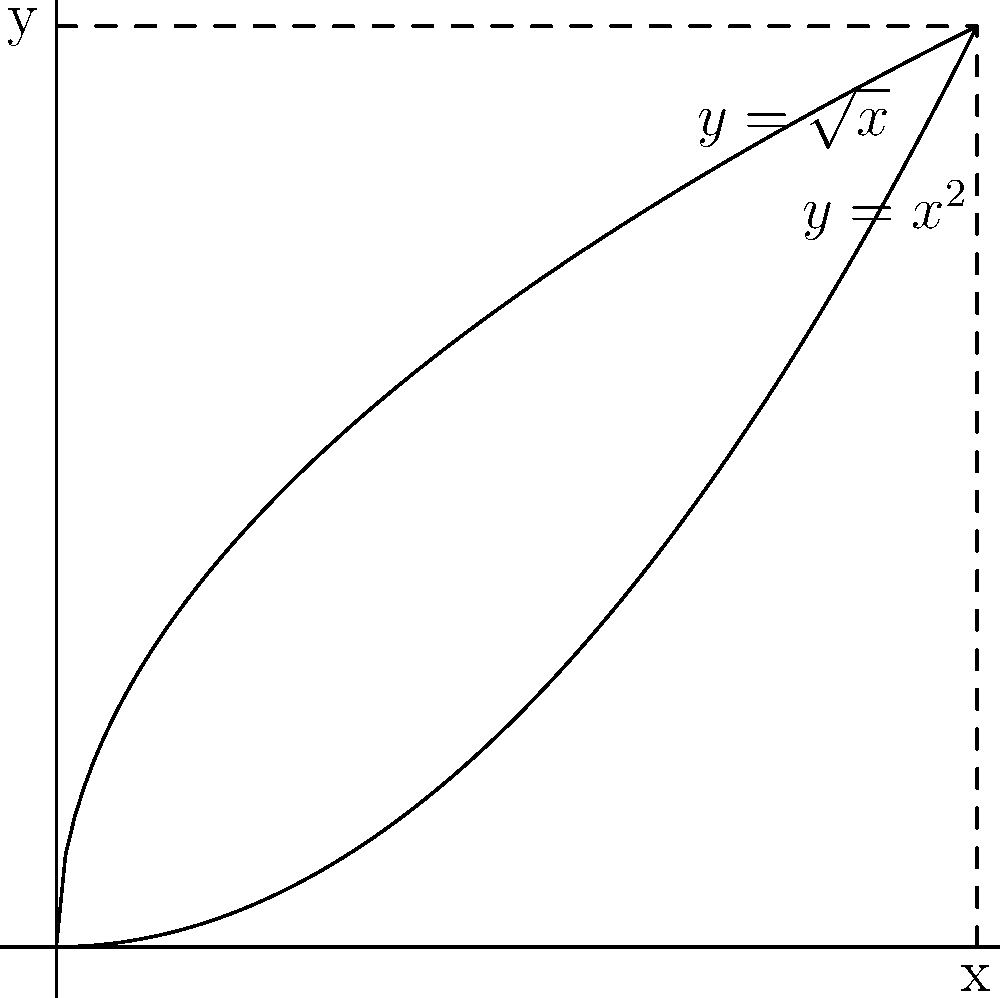Consider the region bounded by the curves $y=\sqrt{x}$ and $y=x^2$ from $x=0$ to $x=1$. Find the volume of the solid formed when this region is rotated about the y-axis. To find the volume of the solid formed by rotating the region about the y-axis, we'll use the washer method:

1) First, identify the outer and inner functions:
   Outer: $r_1 = \sqrt{x}$
   Inner: $r_2 = x^2$

2) Set up the integral. The volume is given by:
   $$V = \pi \int_a^b [(r_1(y))^2 - (r_2(y))^2] dy$$

3) We need to express x in terms of y for both functions:
   For $y = \sqrt{x}$: $x = y^2$
   For $y = x^2$: $x = \sqrt{y}$

4) Determine the limits of integration:
   Bottom limit: $y = 0$
   Top limit: where the curves intersect, $\sqrt{x} = x^2$, which is at $x = 1$, so $y = 1$

5) Set up the integral:
   $$V = \pi \int_0^1 [y^2 - (\sqrt{y})^2] dy$$

6) Simplify:
   $$V = \pi \int_0^1 [y^2 - y] dy$$

7) Integrate:
   $$V = \pi [\frac{y^3}{3} - \frac{y^2}{2}]_0^1$$

8) Evaluate the integral:
   $$V = \pi [(\frac{1}{3} - \frac{1}{2}) - (0 - 0)]$$
   $$V = \pi [\frac{1}{3} - \frac{1}{2}] = \pi [-\frac{1}{6}]$$

9) Simplify:
   $$V = -\frac{\pi}{6}$$
Answer: $\frac{\pi}{6}$ cubic units 